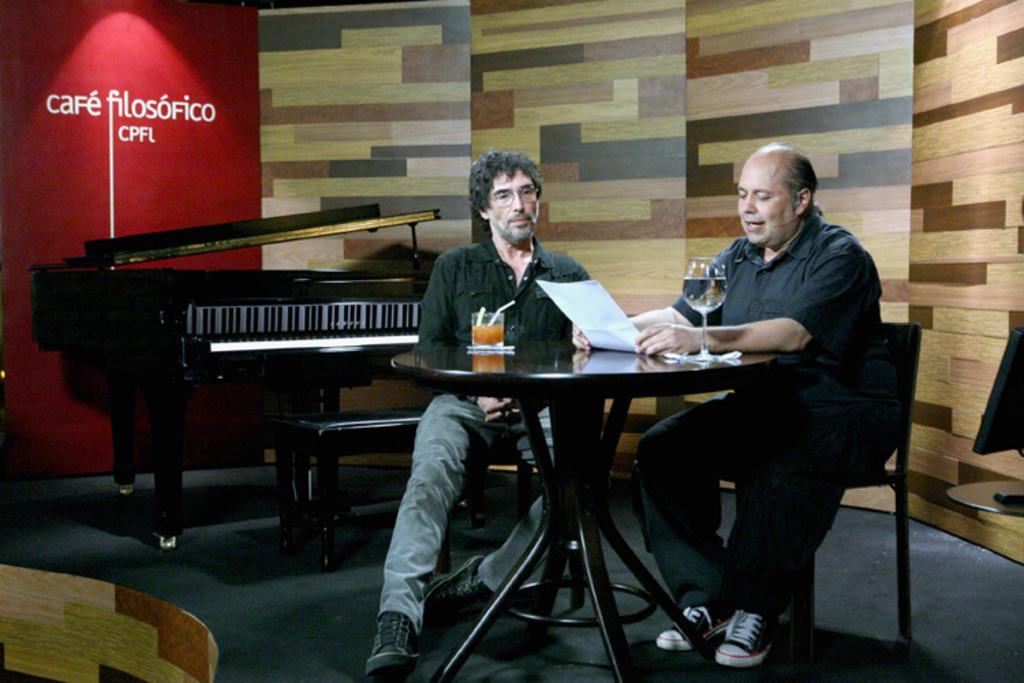How many people are sitting in front of the table in the image? There are two people sitting in front of the table in the image. What is one person doing with their hands? One person is holding a paper. What can be seen on the table? There is a glass on the table. What type of musical instrument is visible in the image? There is a piano at the back side. What is visible behind the people and the table? There is a wall visible in the image. What type of tree can be seen growing through the table in the image? There is no tree growing through the table in the image; it is a wall visible behind the people and the table. 